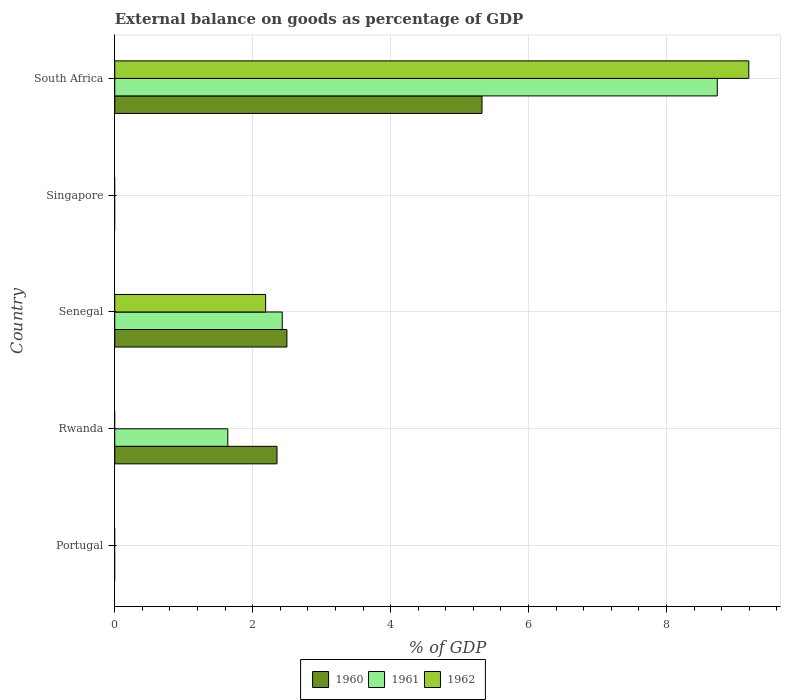How many bars are there on the 2nd tick from the bottom?
Your response must be concise. 2. What is the label of the 3rd group of bars from the top?
Your answer should be compact. Senegal. In how many cases, is the number of bars for a given country not equal to the number of legend labels?
Your answer should be compact. 3. What is the external balance on goods as percentage of GDP in 1961 in Senegal?
Your answer should be compact. 2.43. Across all countries, what is the maximum external balance on goods as percentage of GDP in 1961?
Your answer should be compact. 8.74. Across all countries, what is the minimum external balance on goods as percentage of GDP in 1960?
Give a very brief answer. 0. In which country was the external balance on goods as percentage of GDP in 1961 maximum?
Your response must be concise. South Africa. What is the total external balance on goods as percentage of GDP in 1961 in the graph?
Provide a succinct answer. 12.81. What is the difference between the external balance on goods as percentage of GDP in 1961 in Rwanda and that in South Africa?
Provide a short and direct response. -7.1. What is the difference between the external balance on goods as percentage of GDP in 1961 in Singapore and the external balance on goods as percentage of GDP in 1960 in Senegal?
Give a very brief answer. -2.5. What is the average external balance on goods as percentage of GDP in 1962 per country?
Your answer should be compact. 2.28. What is the difference between the external balance on goods as percentage of GDP in 1960 and external balance on goods as percentage of GDP in 1962 in South Africa?
Offer a terse response. -3.87. What is the ratio of the external balance on goods as percentage of GDP in 1960 in Rwanda to that in South Africa?
Give a very brief answer. 0.44. What is the difference between the highest and the second highest external balance on goods as percentage of GDP in 1960?
Your answer should be compact. 2.83. What is the difference between the highest and the lowest external balance on goods as percentage of GDP in 1962?
Your answer should be very brief. 9.19. In how many countries, is the external balance on goods as percentage of GDP in 1960 greater than the average external balance on goods as percentage of GDP in 1960 taken over all countries?
Your answer should be compact. 3. How many bars are there?
Your answer should be compact. 8. Are all the bars in the graph horizontal?
Your answer should be compact. Yes. How many countries are there in the graph?
Provide a succinct answer. 5. Does the graph contain any zero values?
Your answer should be compact. Yes. Does the graph contain grids?
Your answer should be very brief. Yes. Where does the legend appear in the graph?
Your response must be concise. Bottom center. What is the title of the graph?
Your answer should be very brief. External balance on goods as percentage of GDP. Does "1994" appear as one of the legend labels in the graph?
Offer a terse response. No. What is the label or title of the X-axis?
Provide a succinct answer. % of GDP. What is the % of GDP of 1960 in Portugal?
Offer a very short reply. 0. What is the % of GDP in 1962 in Portugal?
Give a very brief answer. 0. What is the % of GDP in 1960 in Rwanda?
Make the answer very short. 2.35. What is the % of GDP in 1961 in Rwanda?
Provide a succinct answer. 1.64. What is the % of GDP in 1960 in Senegal?
Ensure brevity in your answer.  2.5. What is the % of GDP in 1961 in Senegal?
Your response must be concise. 2.43. What is the % of GDP of 1962 in Senegal?
Your answer should be very brief. 2.19. What is the % of GDP of 1960 in Singapore?
Offer a very short reply. 0. What is the % of GDP in 1961 in Singapore?
Provide a short and direct response. 0. What is the % of GDP in 1960 in South Africa?
Make the answer very short. 5.33. What is the % of GDP in 1961 in South Africa?
Keep it short and to the point. 8.74. What is the % of GDP of 1962 in South Africa?
Your answer should be very brief. 9.19. Across all countries, what is the maximum % of GDP of 1960?
Offer a very short reply. 5.33. Across all countries, what is the maximum % of GDP in 1961?
Your answer should be compact. 8.74. Across all countries, what is the maximum % of GDP in 1962?
Your answer should be compact. 9.19. Across all countries, what is the minimum % of GDP of 1960?
Offer a very short reply. 0. Across all countries, what is the minimum % of GDP in 1961?
Offer a terse response. 0. What is the total % of GDP in 1960 in the graph?
Provide a short and direct response. 10.17. What is the total % of GDP of 1961 in the graph?
Provide a succinct answer. 12.81. What is the total % of GDP in 1962 in the graph?
Provide a succinct answer. 11.38. What is the difference between the % of GDP in 1960 in Rwanda and that in Senegal?
Make the answer very short. -0.14. What is the difference between the % of GDP of 1961 in Rwanda and that in Senegal?
Ensure brevity in your answer.  -0.79. What is the difference between the % of GDP in 1960 in Rwanda and that in South Africa?
Make the answer very short. -2.97. What is the difference between the % of GDP of 1961 in Rwanda and that in South Africa?
Make the answer very short. -7.1. What is the difference between the % of GDP in 1960 in Senegal and that in South Africa?
Your answer should be very brief. -2.83. What is the difference between the % of GDP of 1961 in Senegal and that in South Africa?
Offer a very short reply. -6.31. What is the difference between the % of GDP of 1962 in Senegal and that in South Africa?
Make the answer very short. -7.01. What is the difference between the % of GDP in 1960 in Rwanda and the % of GDP in 1961 in Senegal?
Your response must be concise. -0.08. What is the difference between the % of GDP of 1960 in Rwanda and the % of GDP of 1962 in Senegal?
Offer a very short reply. 0.16. What is the difference between the % of GDP in 1961 in Rwanda and the % of GDP in 1962 in Senegal?
Your response must be concise. -0.55. What is the difference between the % of GDP of 1960 in Rwanda and the % of GDP of 1961 in South Africa?
Offer a very short reply. -6.38. What is the difference between the % of GDP in 1960 in Rwanda and the % of GDP in 1962 in South Africa?
Offer a very short reply. -6.84. What is the difference between the % of GDP of 1961 in Rwanda and the % of GDP of 1962 in South Africa?
Provide a succinct answer. -7.55. What is the difference between the % of GDP of 1960 in Senegal and the % of GDP of 1961 in South Africa?
Your answer should be compact. -6.24. What is the difference between the % of GDP in 1960 in Senegal and the % of GDP in 1962 in South Africa?
Offer a very short reply. -6.7. What is the difference between the % of GDP in 1961 in Senegal and the % of GDP in 1962 in South Africa?
Provide a short and direct response. -6.77. What is the average % of GDP in 1960 per country?
Provide a succinct answer. 2.04. What is the average % of GDP of 1961 per country?
Ensure brevity in your answer.  2.56. What is the average % of GDP in 1962 per country?
Your response must be concise. 2.28. What is the difference between the % of GDP in 1960 and % of GDP in 1961 in Rwanda?
Your response must be concise. 0.71. What is the difference between the % of GDP in 1960 and % of GDP in 1961 in Senegal?
Ensure brevity in your answer.  0.07. What is the difference between the % of GDP of 1960 and % of GDP of 1962 in Senegal?
Offer a very short reply. 0.31. What is the difference between the % of GDP in 1961 and % of GDP in 1962 in Senegal?
Your response must be concise. 0.24. What is the difference between the % of GDP in 1960 and % of GDP in 1961 in South Africa?
Provide a short and direct response. -3.41. What is the difference between the % of GDP in 1960 and % of GDP in 1962 in South Africa?
Your answer should be very brief. -3.87. What is the difference between the % of GDP of 1961 and % of GDP of 1962 in South Africa?
Give a very brief answer. -0.46. What is the ratio of the % of GDP in 1960 in Rwanda to that in Senegal?
Your answer should be compact. 0.94. What is the ratio of the % of GDP of 1961 in Rwanda to that in Senegal?
Keep it short and to the point. 0.68. What is the ratio of the % of GDP of 1960 in Rwanda to that in South Africa?
Your answer should be very brief. 0.44. What is the ratio of the % of GDP of 1961 in Rwanda to that in South Africa?
Offer a very short reply. 0.19. What is the ratio of the % of GDP in 1960 in Senegal to that in South Africa?
Ensure brevity in your answer.  0.47. What is the ratio of the % of GDP in 1961 in Senegal to that in South Africa?
Offer a terse response. 0.28. What is the ratio of the % of GDP in 1962 in Senegal to that in South Africa?
Your response must be concise. 0.24. What is the difference between the highest and the second highest % of GDP in 1960?
Provide a short and direct response. 2.83. What is the difference between the highest and the second highest % of GDP of 1961?
Provide a succinct answer. 6.31. What is the difference between the highest and the lowest % of GDP of 1960?
Your answer should be compact. 5.33. What is the difference between the highest and the lowest % of GDP of 1961?
Your answer should be very brief. 8.74. What is the difference between the highest and the lowest % of GDP in 1962?
Your answer should be compact. 9.19. 